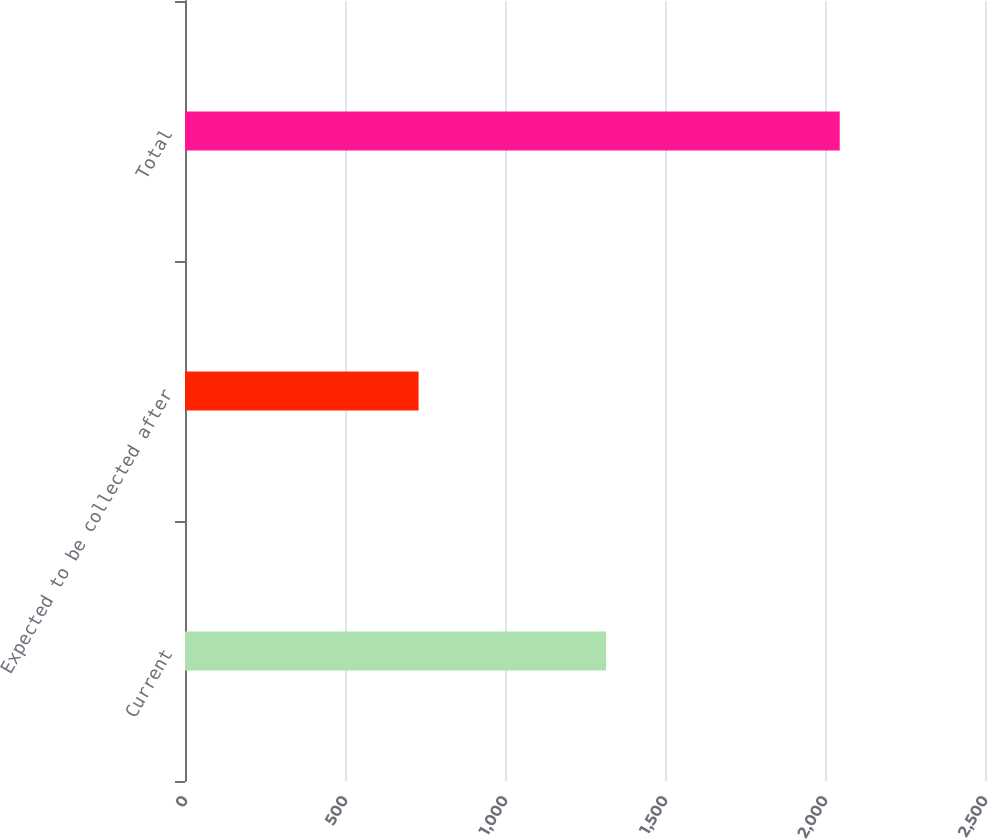Convert chart to OTSL. <chart><loc_0><loc_0><loc_500><loc_500><bar_chart><fcel>Current<fcel>Expected to be collected after<fcel>Total<nl><fcel>1316<fcel>730<fcel>2046<nl></chart> 